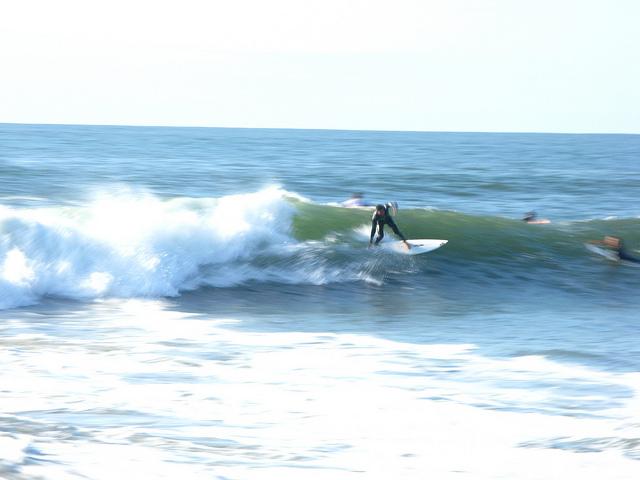How many people are in the water?
Be succinct. 4. Is the man a professional surfer?
Write a very short answer. Yes. Are the waves big?
Be succinct. Yes. 